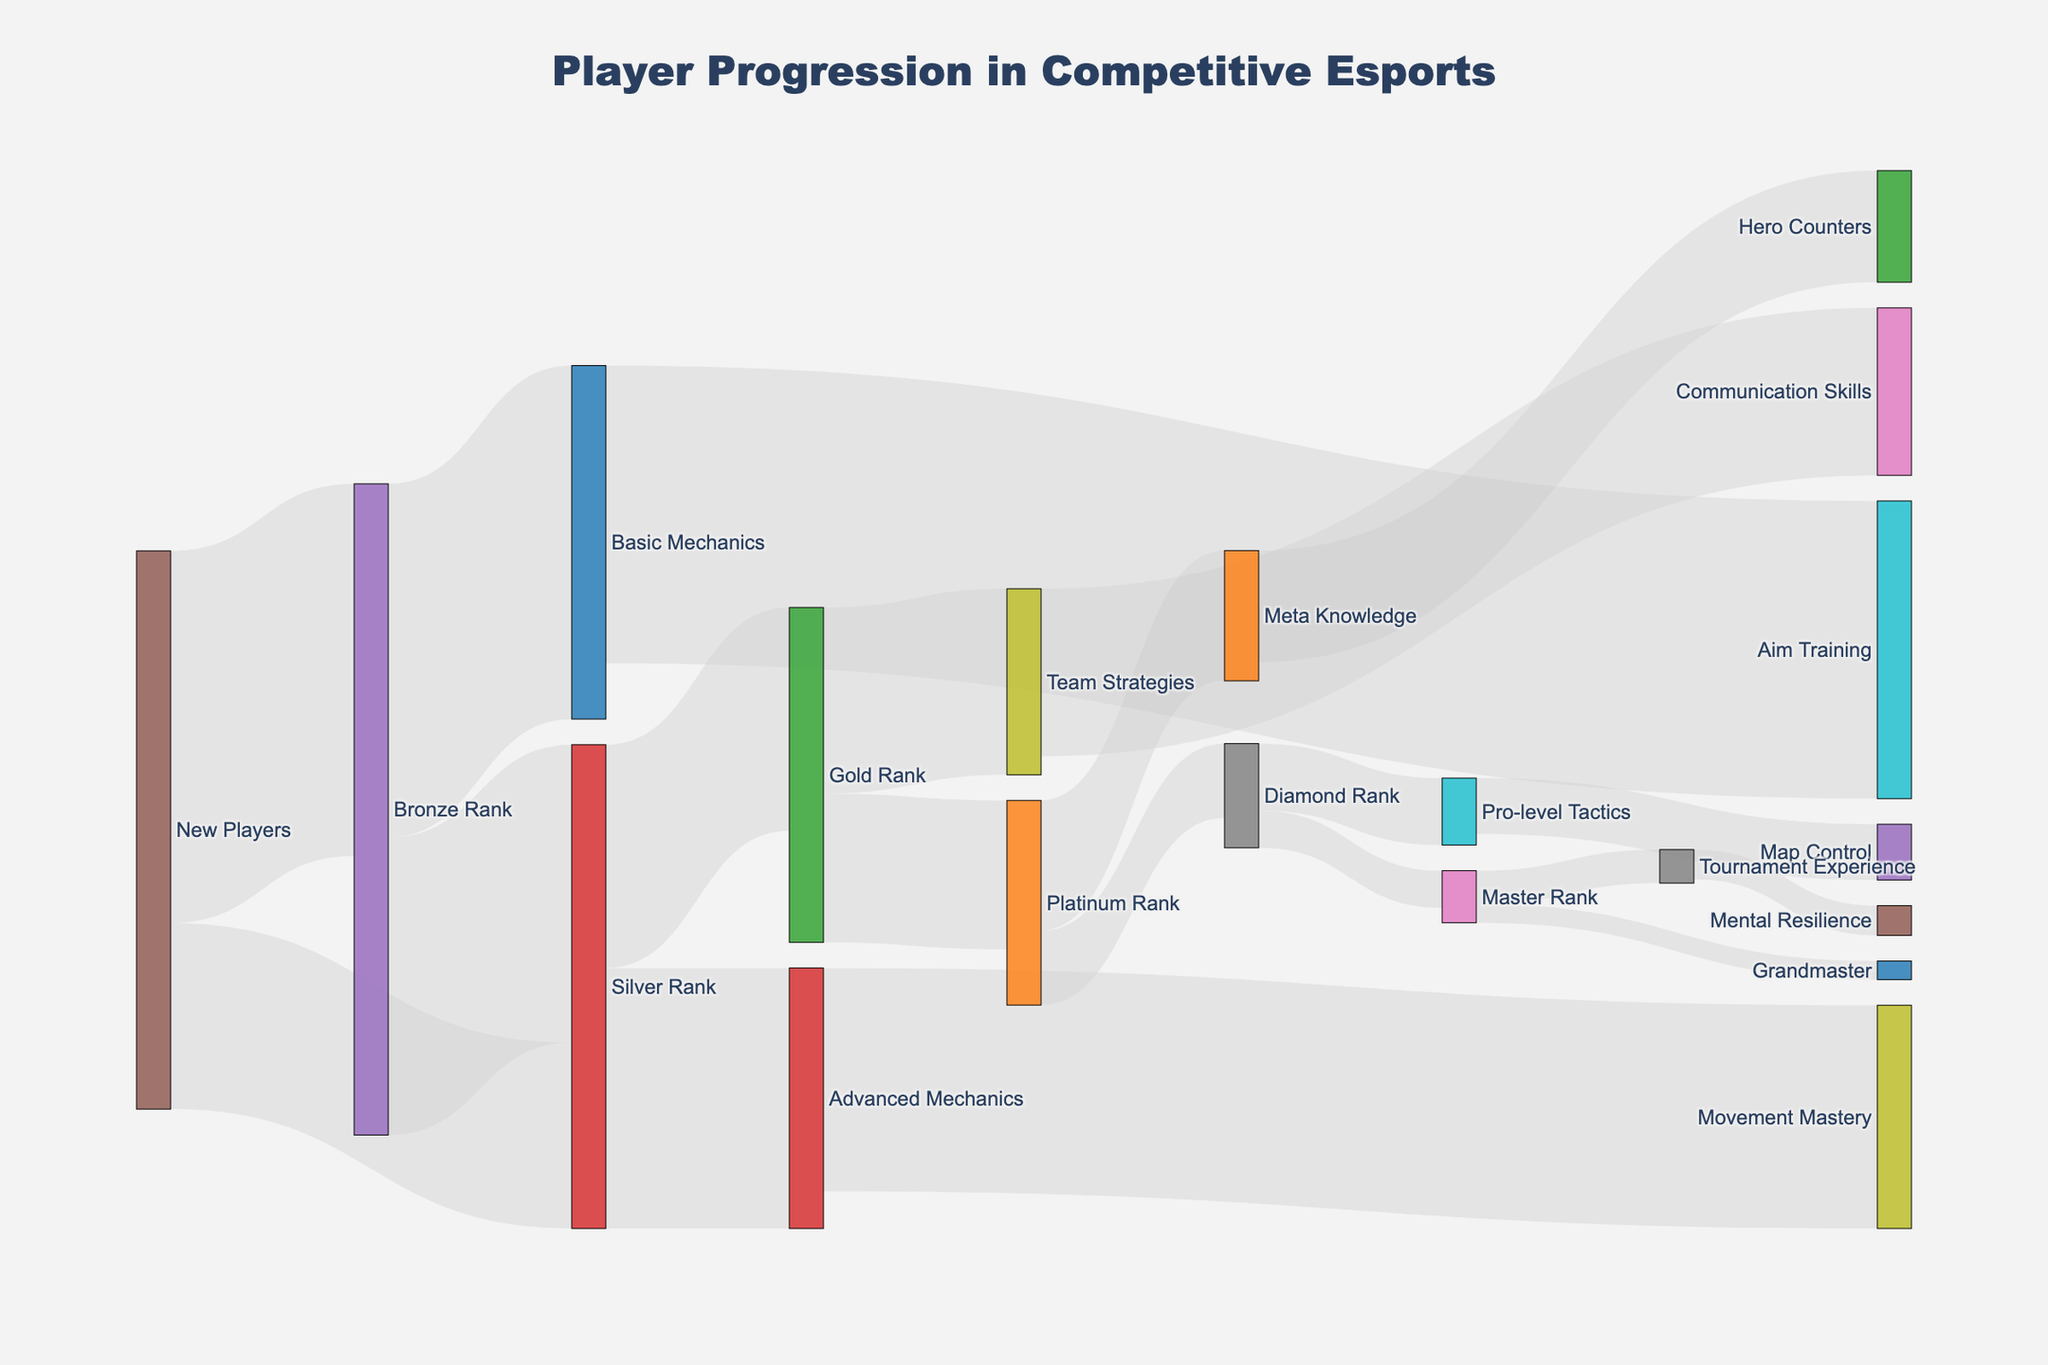What's the title of this Sankey diagram? The title is usually found at the top center of the diagram. It gives an overview of what the Sankey diagram represents.
Answer: Player Progression in Competitive Esports What are the nodes connected to "Bronze Rank"? To find the nodes connected to "Bronze Rank", look at the lines extending to and from it.
Answer: Silver Rank, Basic Mechanics How many new players reach the Silver Rank directly? Trace the line labeled "New Players" that connects directly to "Silver Rank" and check its value.
Answer: 500 Which node has the highest skill progression from "Gold Rank"? Identify the nodes that "Gold Rank" connects to, and compare their values.
Answer: Platinum Rank What is the total number of players that progress from "Silver Rank" to "Gold Rank" and from "Gold Rank" to "Platinum Rank"? Add the values of players progressing from "Silver Rank" to "Gold Rank" and from "Gold Rank" to "Platinum Rank".
Answer: 600 + 400 = 1000 Compare the number of players who acquire "Advanced Mechanics" from "Silver Rank" and those acquiring "Basic Mechanics" from "Bronze Rank". Check the values of the connections from "Silver Rank" to "Advanced Mechanics" and from "Bronze Rank" to "Basic Mechanics".
Answer: 700 vs 950 What skill is gained by 600 players from "Advanced Mechanics"? Look at the target node connected from "Advanced Mechanics" with a value of 600.
Answer: Movement Mastery List the progression path for players who go from "New Players" to "Gold Rank". Trace the path starting from "New Players" and ending at "Gold Rank", passing through intermediate ranks.
Answer: New Players → Bronze Rank → Silver Rank → Gold Rank Compare the number of players who reach "Master Rank" and "Grandmaster". Look at the values of the lines connecting to "Master Rank" and "Grandmaster".
Answer: 100 vs 50 What is the next step after acquiring "Team Strategies" for 450 players? Identify the node that "Team Strategies" leads to with a value of 450.
Answer: Communication Skills 